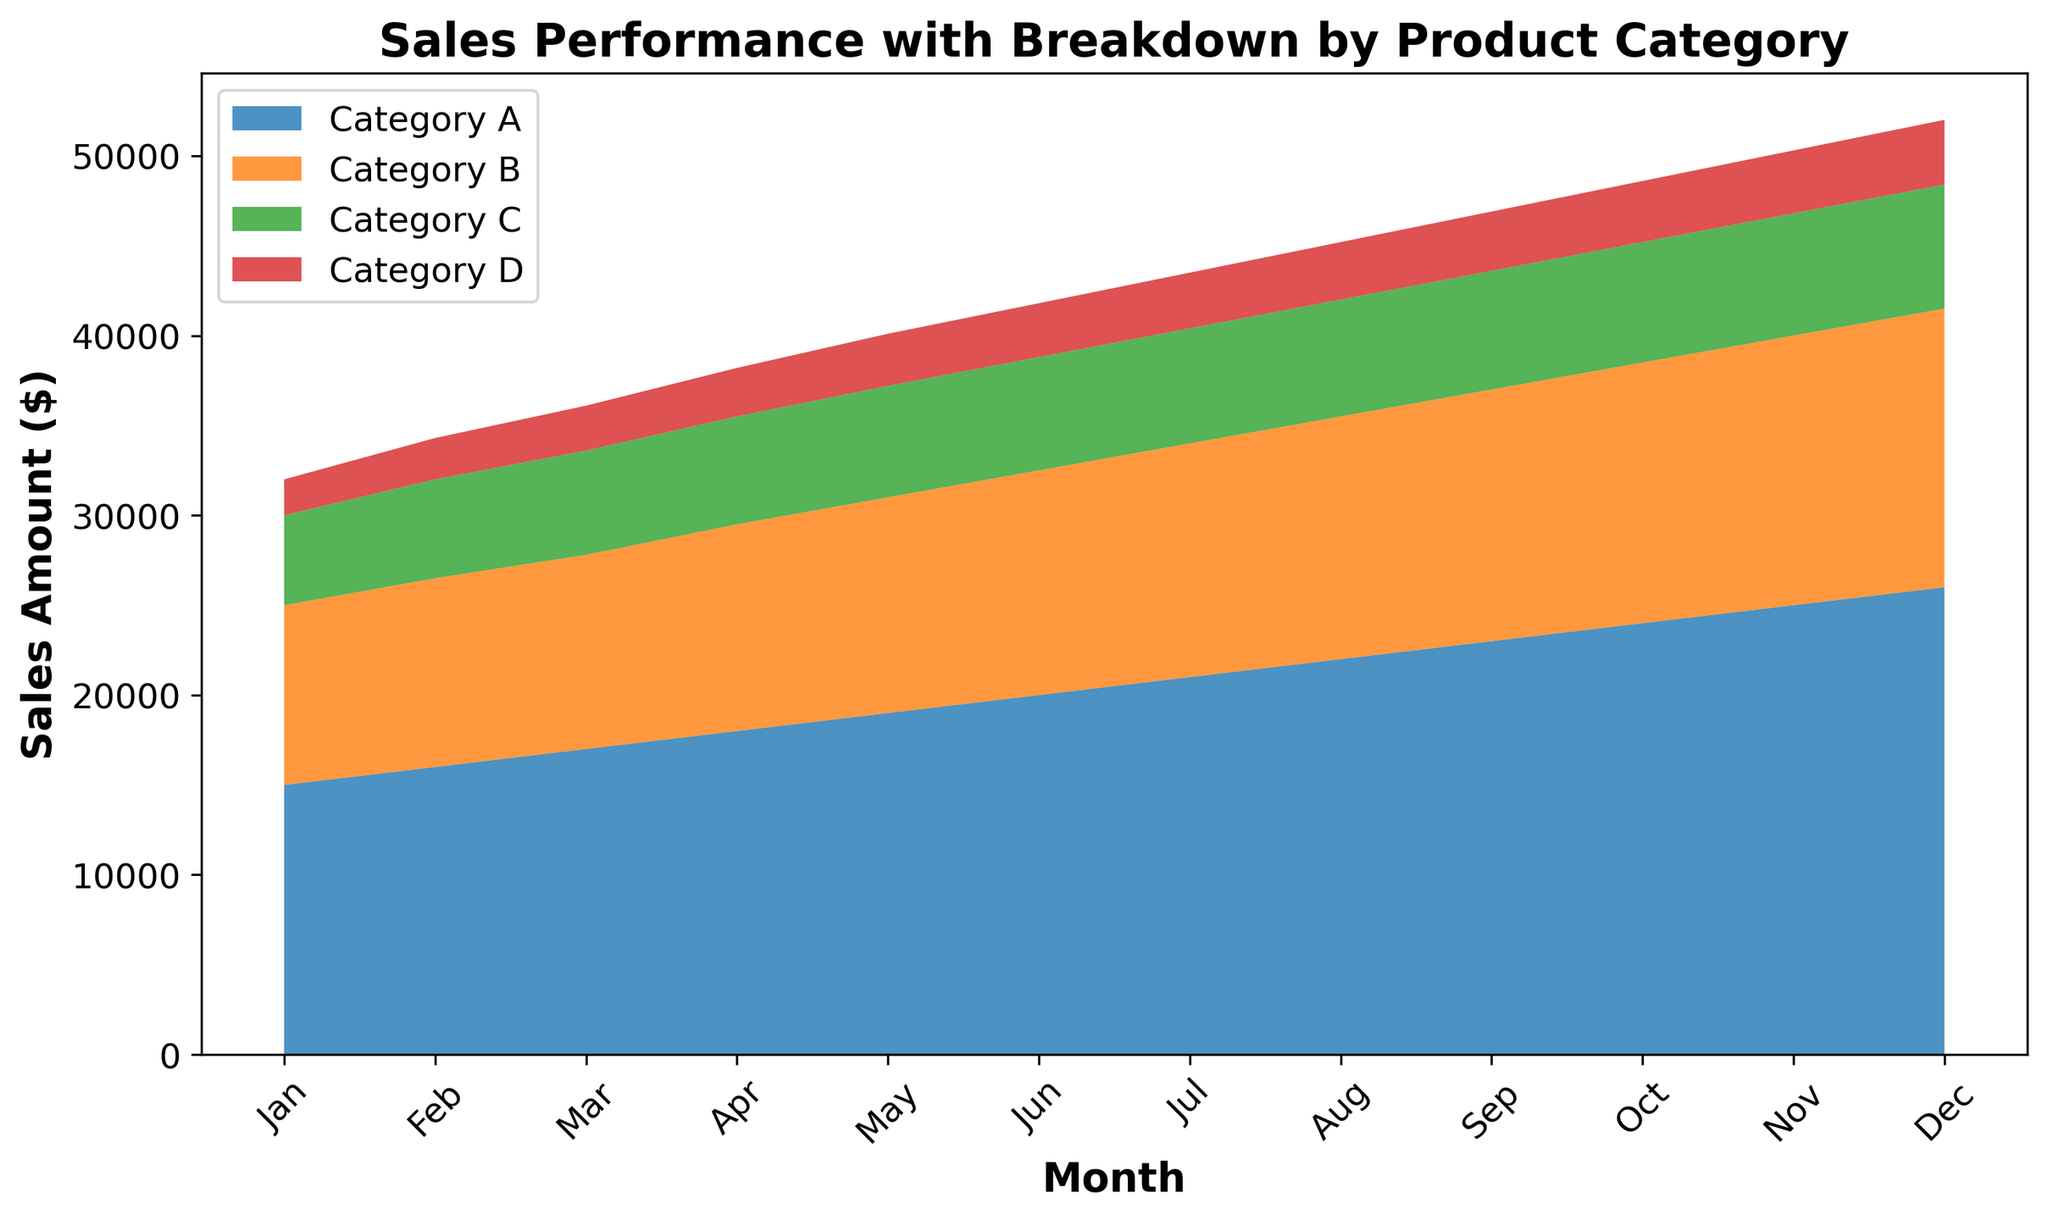What is the total sales amount for Category A in the entire year? To find the total, sum the sales values of Category A across all the months. (15000 + 16000 + 17000 + 18000 + 19000 + 20000 + 21000 + 22000 + 23000 + 24000 + 25000 + 26000) = 256000
Answer: 256000 Which product category showed the highest sales in December? Look at the values for December and compare each product category. Category A: 26000, Category B: 15500, Category C: 6900, Category D: 3600. Category A has the highest value in December.
Answer: Category A What is the difference in sales between Category A and Category B in July? Find the sales amounts for Category A and Category B in July and calculate the difference. Category A: 21000, Category B: 13000. The difference is 21000 - 13000 = 8000
Answer: 8000 How did the combined sales for all categories trend over the year? Observing the graph, the total area under the curves (representing combined sales) increases steadily from January to December. This indicates a positive upward trend.
Answer: Upward trend Which category had the smallest total sales amount over the entire year? Sum the sales values for each category across all the months. Category A: 256000, Category B: 157800, Category C: 74300, Category D: 37400. Category D has the smallest total sales amount.
Answer: Category D During which month did Category C experience the highest sales? Look at the values for Category C across all months to identify the highest value. The highest sales amount for Category C is 6900 in December.
Answer: December What color represents Category B in the chart? Locate the visual representation of Category B within the stacked area chart legend or the graph sections. The color used for Category B is visually identifiable as one of the areas.
Answer: Provided the graph legend indicates the answer What is the average monthly sales for Category D? Calculate the average by summing the sales values and dividing by the number of months. (2000 + 2300 + 2500 + 2700 + 2900 + 3000 + 3100 + 3200 + 3300 + 3400 + 3500 + 3600) / 12 = 29400 / 12 = 2950
Answer: 2950 Which two consecutive months had the largest increase in sales for Category A? Examine the month-to-month sales changes for Category A and identify the largest increase. Jan to Feb: 1000, Feb to Mar: 1000, ..., Nov to Dec: 1000. The largest is a consistent 1000 from May to June.
Answer: May to June 